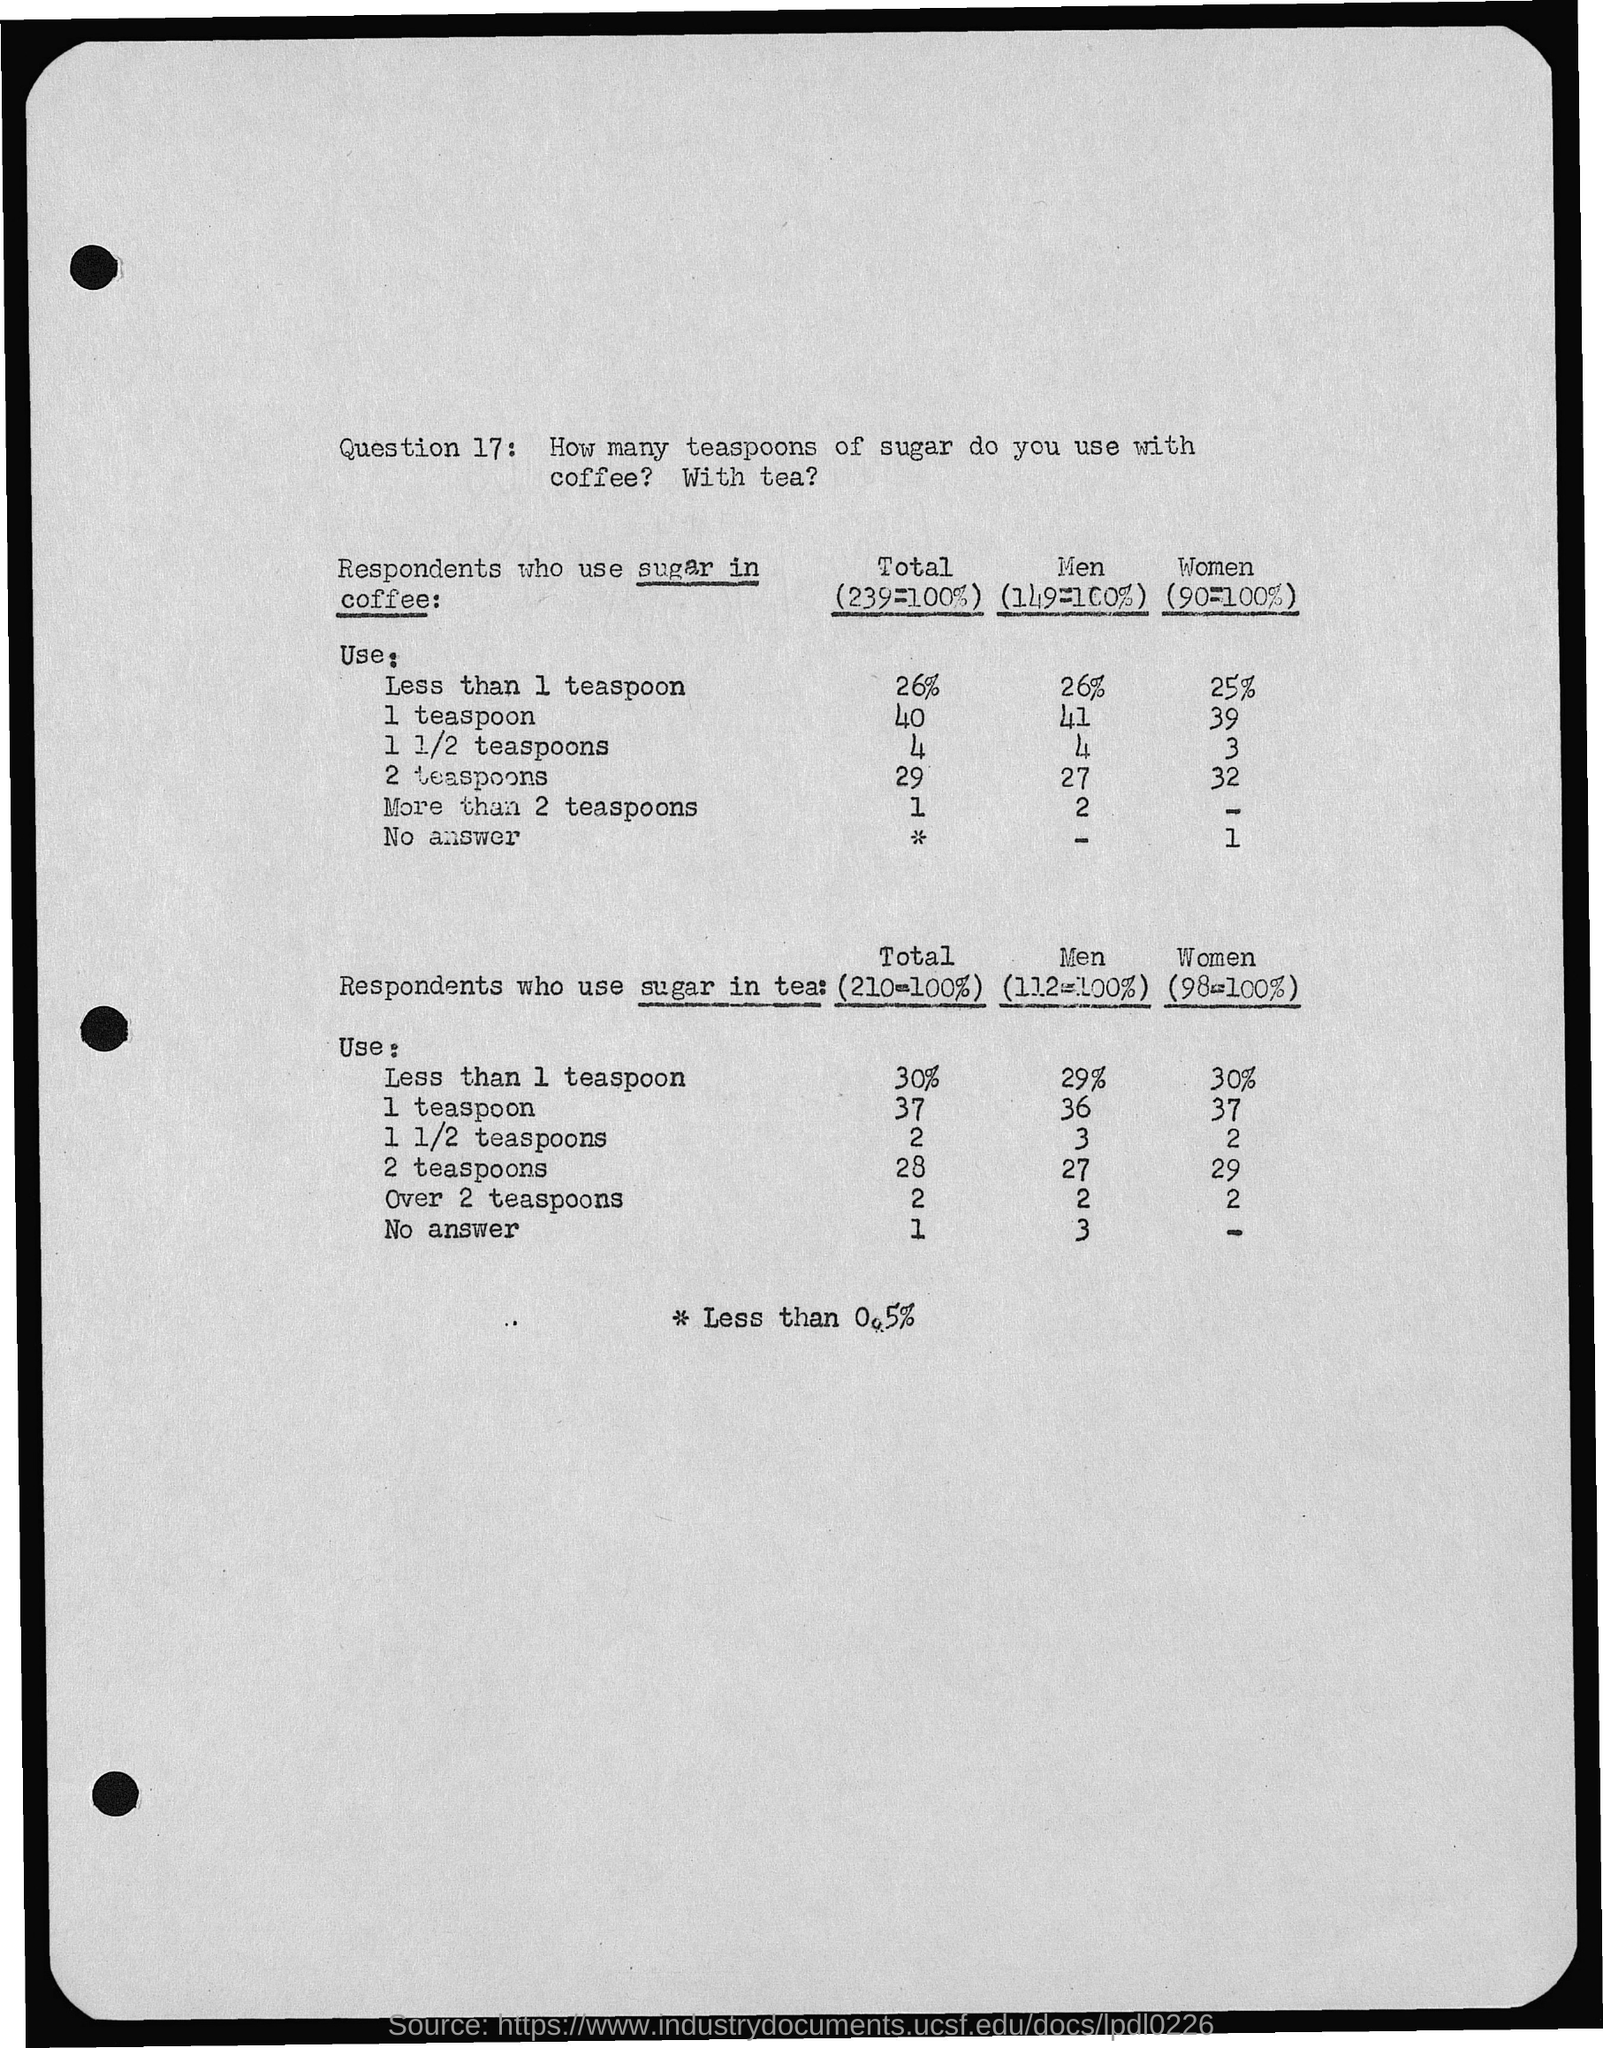List a handful of essential elements in this visual. A small percentage of women use less than 1 teaspoon of sugar in their coffee, according to a recent survey. According to a survey, approximately 30% of women use less than 1 teaspoon of sugar in their tea. A recent study revealed that only 29% of men use less than 1 teaspoon of sugar in their tea. According to a survey, 26% of men consume less than 1 teaspoon of sugar in their coffee. In Question 17, I asked how many teaspoons of sugar are used with coffee and tea respectively. 